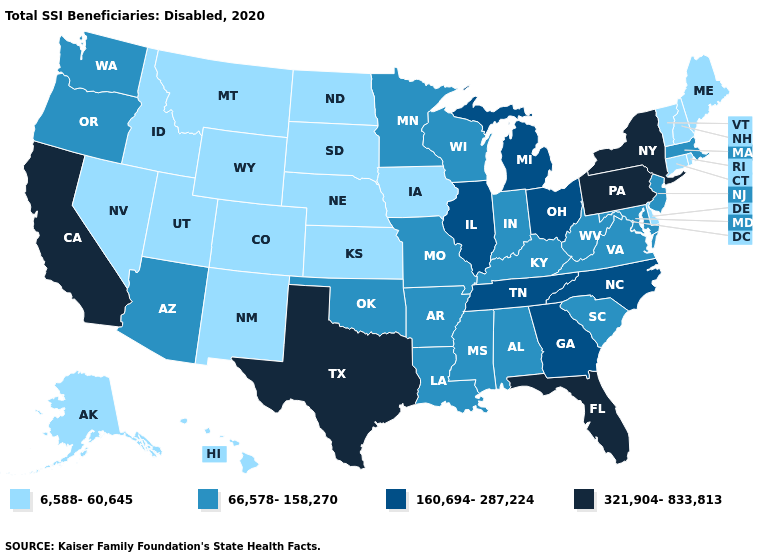Which states have the lowest value in the USA?
Short answer required. Alaska, Colorado, Connecticut, Delaware, Hawaii, Idaho, Iowa, Kansas, Maine, Montana, Nebraska, Nevada, New Hampshire, New Mexico, North Dakota, Rhode Island, South Dakota, Utah, Vermont, Wyoming. Name the states that have a value in the range 6,588-60,645?
Concise answer only. Alaska, Colorado, Connecticut, Delaware, Hawaii, Idaho, Iowa, Kansas, Maine, Montana, Nebraska, Nevada, New Hampshire, New Mexico, North Dakota, Rhode Island, South Dakota, Utah, Vermont, Wyoming. Does Pennsylvania have the highest value in the USA?
Write a very short answer. Yes. Does Alabama have the highest value in the South?
Answer briefly. No. Which states hav the highest value in the West?
Answer briefly. California. What is the value of Ohio?
Quick response, please. 160,694-287,224. Among the states that border Wisconsin , which have the lowest value?
Answer briefly. Iowa. What is the lowest value in states that border Oklahoma?
Answer briefly. 6,588-60,645. What is the highest value in the USA?
Write a very short answer. 321,904-833,813. What is the value of New Hampshire?
Be succinct. 6,588-60,645. Name the states that have a value in the range 321,904-833,813?
Quick response, please. California, Florida, New York, Pennsylvania, Texas. Among the states that border Missouri , does Iowa have the lowest value?
Keep it brief. Yes. What is the highest value in the USA?
Answer briefly. 321,904-833,813. Which states hav the highest value in the MidWest?
Give a very brief answer. Illinois, Michigan, Ohio. 